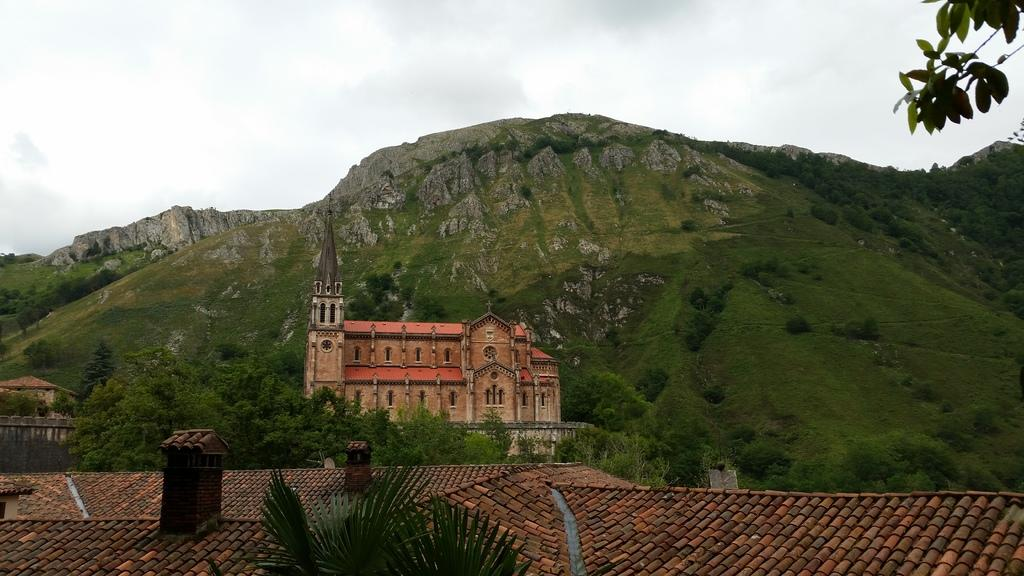What type of vegetation can be seen in the image? There are trees in the image. What is the color of the trees? The trees are green in color. What type of structure is present in the image? There is a building with a roof in the image. How many buildings can be seen in the image? There are other buildings visible in the image. What is visible in the background of the image? There is a mountain and the sky visible in the background of the image. What type of coal is being used to paint the canvas in the image? There is no coal or canvas present in the image. What flavor of toothpaste is being used to clean the mountain in the image? There is no toothpaste or cleaning activity depicted in the image. 